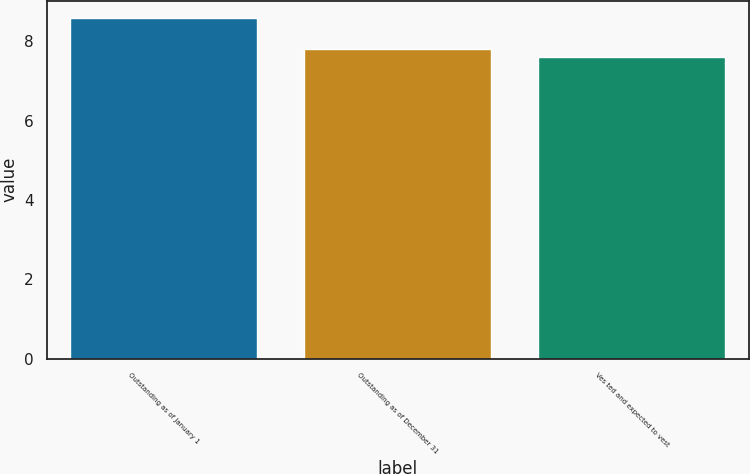Convert chart to OTSL. <chart><loc_0><loc_0><loc_500><loc_500><bar_chart><fcel>Outstanding as of January 1<fcel>Outstanding as of December 31<fcel>Ves ted and expected to vest<nl><fcel>8.59<fcel>7.81<fcel>7.6<nl></chart> 